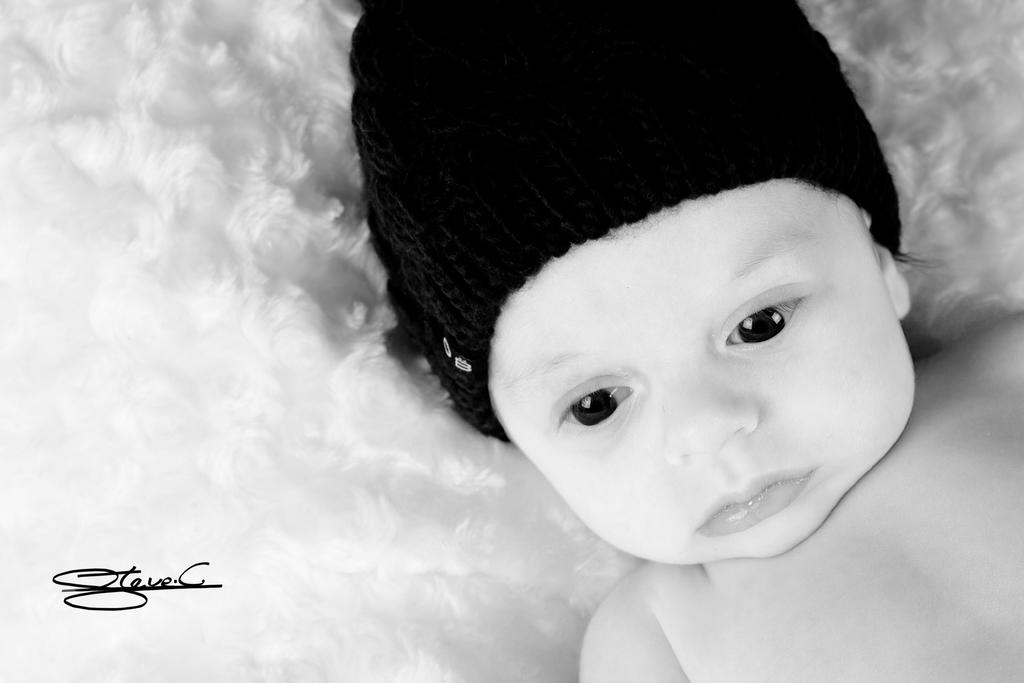What is the color scheme of the image? The image is black and white. What is the main subject of the image? There is a picture of a baby in the image. What is the baby wearing on their head? The baby is wearing a black hat. What color is the text written on the image? The text is written in black color on the image. Can you see the baby's nose in the image? The image is in black and white, so it is not possible to see the color of the baby's nose. However, the baby's nose is not a separate object that can be seen or not seen in the image. --- 